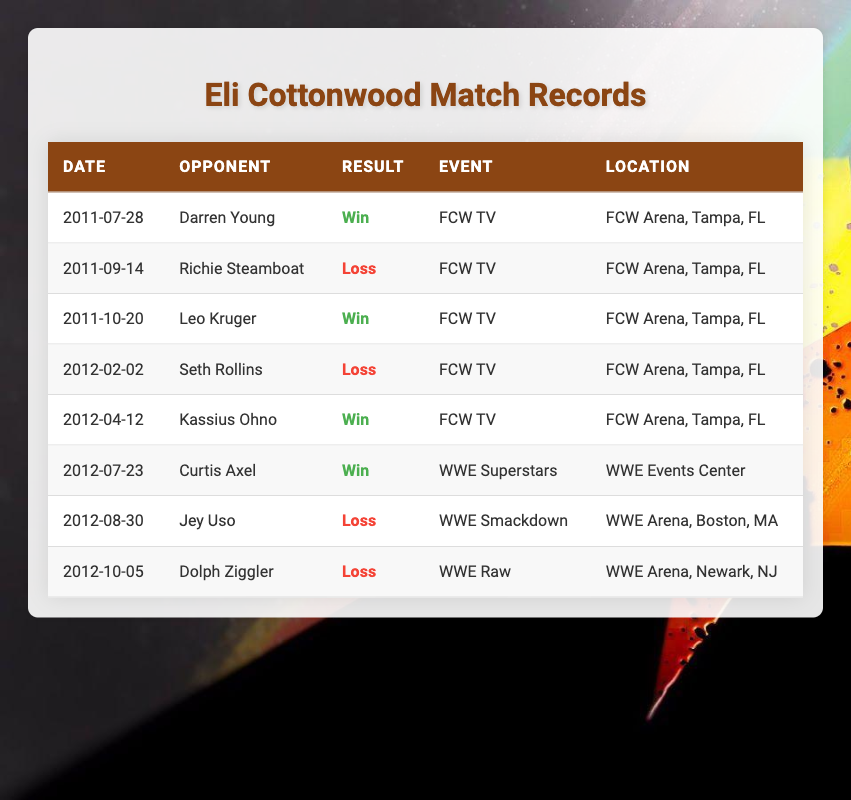What is Eli Cottonwood's match result against Darren Young? In the table, we can locate the row for the match on the date of 2011-07-28 against Darren Young. The Result column states "Win" for this match.
Answer: Win How many matches did Eli Cottonwood lose? Counting the rows in the Result column, we identify three matches where the Result is "Loss": against Richie Steamboat, Seth Rollins, Jey Uso, and Dolph Ziggler.
Answer: 4 What was the location of Eli Cottonwood's win against Kassius Ohno? By examining the timeline of matches, we find that Eli's victory against Kassius Ohno occurred on 2012-04-12. Referring to the Location column for this match, it states "FCW Arena, Tampa, FL".
Answer: FCW Arena, Tampa, FL How many total matches did Eli Cottonwood compete in according to the data? By counting all the rows in the table, we see there are 8 entries. Thus, Eli Cottonwood competed in a total of 8 matches.
Answer: 8 Did Eli Cottonwood ever win a match at WWE Superstars? Looking through the events listed, we find that Eli Cottonwood did win a match at WWE Superstars against Curtis Axel on 2012-07-23.
Answer: Yes What is Eli Cottonwood's win-loss ratio based on the recorded matches? To find the win-loss ratio, we count 4 wins and 4 losses. Therefore, the win-loss ratio is calculated as 4 wins to 4 losses, which simplifies to 1:1.
Answer: 1:1 What opponent did Eli Cottonwood lose to in WWE Smackdown? Referring to the events listed in the table, we find that he lost to Jey Uso on 2012-08-30 during WWE Smackdown.
Answer: Jey Uso How many matches did Eli Cottonwood lose in the FCW TV events? We check the matches under the event "FCW TV." From the table, he lost to Richie Steamboat and Seth Rollins in FCW TV events, giving us a total of 2 losses in this category.
Answer: 2 